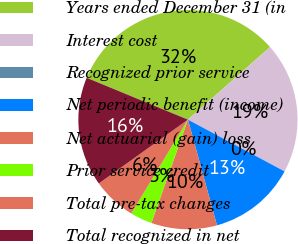<chart> <loc_0><loc_0><loc_500><loc_500><pie_chart><fcel>Years ended December 31 (in<fcel>Interest cost<fcel>Recognized prior service<fcel>Net periodic benefit (income)<fcel>Net actuarial (gain) loss<fcel>Prior service credit<fcel>Total pre-tax changes<fcel>Total recognized in net<nl><fcel>32.24%<fcel>19.35%<fcel>0.01%<fcel>12.9%<fcel>9.68%<fcel>3.24%<fcel>6.46%<fcel>16.13%<nl></chart> 